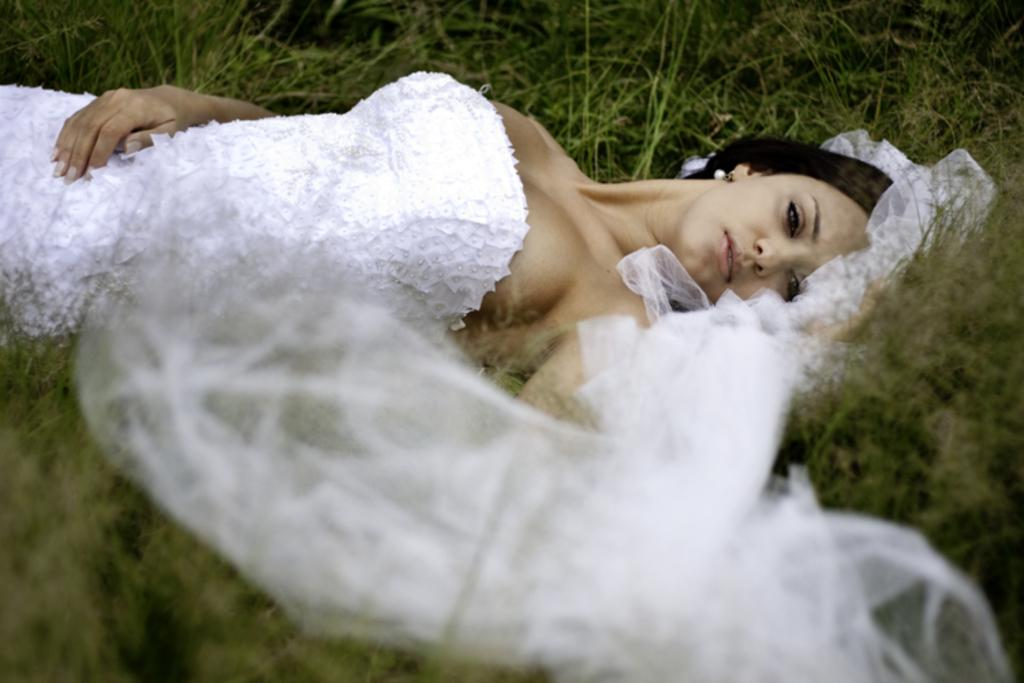Who is the main subject in the image? There is a woman in the image. What is the woman wearing? The woman is wearing a white dress. What is the woman's position in the image? The woman is laying on the ground. What type of natural environment is visible in the image? There is grass visible in the image. What type of border is visible around the woman in the image? There is no border visible around the woman in the image. What type of shoe is the woman wearing in the image? The woman is laying on the ground, and her feet are not visible, so it cannot be determined what type of shoe she is wearing. 